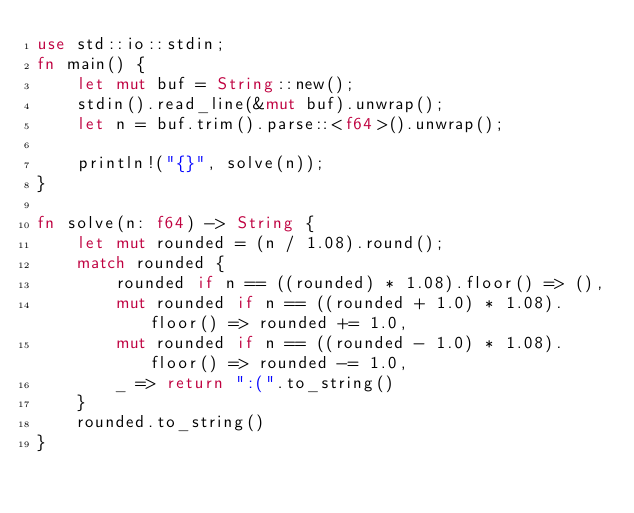<code> <loc_0><loc_0><loc_500><loc_500><_Rust_>use std::io::stdin;
fn main() {
    let mut buf = String::new();
    stdin().read_line(&mut buf).unwrap();
    let n = buf.trim().parse::<f64>().unwrap();

    println!("{}", solve(n));
}

fn solve(n: f64) -> String {
    let mut rounded = (n / 1.08).round();
    match rounded {
        rounded if n == ((rounded) * 1.08).floor() => (),
        mut rounded if n == ((rounded + 1.0) * 1.08).floor() => rounded += 1.0,
        mut rounded if n == ((rounded - 1.0) * 1.08).floor() => rounded -= 1.0,
        _ => return ":(".to_string()
    }
    rounded.to_string()
}</code> 